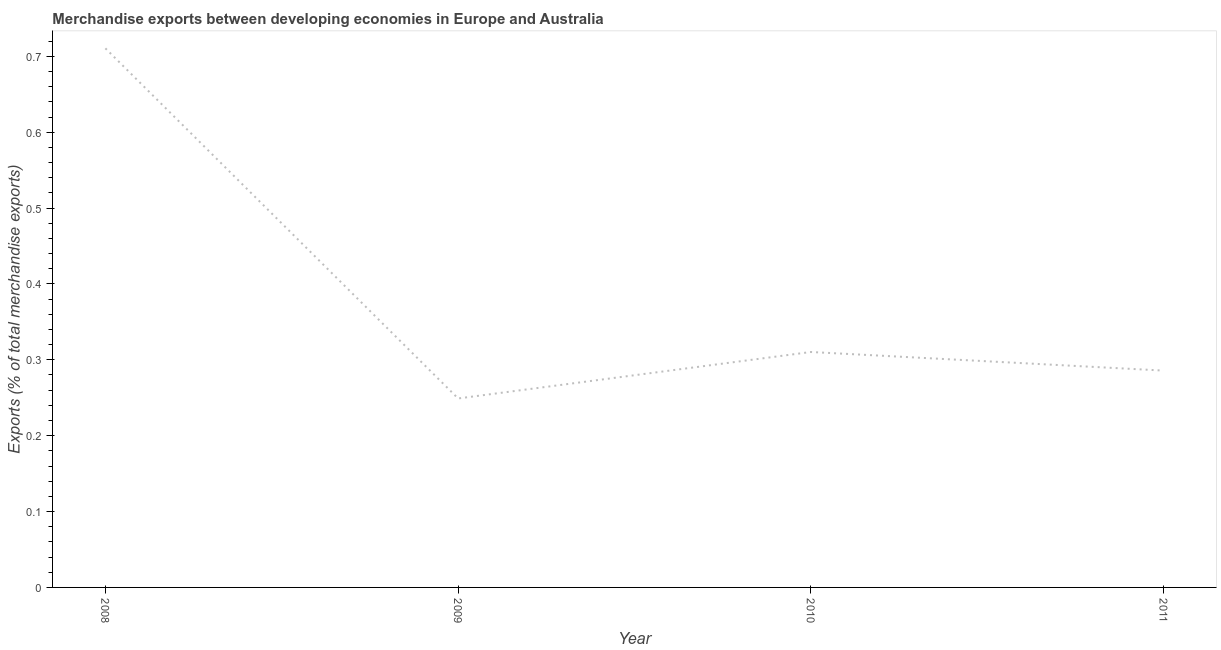What is the merchandise exports in 2011?
Provide a short and direct response. 0.29. Across all years, what is the maximum merchandise exports?
Provide a succinct answer. 0.71. Across all years, what is the minimum merchandise exports?
Provide a succinct answer. 0.25. What is the sum of the merchandise exports?
Offer a terse response. 1.56. What is the difference between the merchandise exports in 2010 and 2011?
Provide a succinct answer. 0.02. What is the average merchandise exports per year?
Your answer should be very brief. 0.39. What is the median merchandise exports?
Keep it short and to the point. 0.3. In how many years, is the merchandise exports greater than 0.16 %?
Provide a succinct answer. 4. What is the ratio of the merchandise exports in 2009 to that in 2010?
Provide a short and direct response. 0.8. Is the merchandise exports in 2010 less than that in 2011?
Your answer should be very brief. No. What is the difference between the highest and the second highest merchandise exports?
Keep it short and to the point. 0.4. What is the difference between the highest and the lowest merchandise exports?
Keep it short and to the point. 0.46. How many lines are there?
Offer a terse response. 1. How many years are there in the graph?
Keep it short and to the point. 4. What is the difference between two consecutive major ticks on the Y-axis?
Provide a short and direct response. 0.1. What is the title of the graph?
Offer a very short reply. Merchandise exports between developing economies in Europe and Australia. What is the label or title of the Y-axis?
Your response must be concise. Exports (% of total merchandise exports). What is the Exports (% of total merchandise exports) of 2008?
Provide a succinct answer. 0.71. What is the Exports (% of total merchandise exports) in 2009?
Your response must be concise. 0.25. What is the Exports (% of total merchandise exports) in 2010?
Offer a very short reply. 0.31. What is the Exports (% of total merchandise exports) of 2011?
Offer a terse response. 0.29. What is the difference between the Exports (% of total merchandise exports) in 2008 and 2009?
Your response must be concise. 0.46. What is the difference between the Exports (% of total merchandise exports) in 2008 and 2010?
Your answer should be compact. 0.4. What is the difference between the Exports (% of total merchandise exports) in 2008 and 2011?
Your response must be concise. 0.42. What is the difference between the Exports (% of total merchandise exports) in 2009 and 2010?
Make the answer very short. -0.06. What is the difference between the Exports (% of total merchandise exports) in 2009 and 2011?
Your answer should be very brief. -0.04. What is the difference between the Exports (% of total merchandise exports) in 2010 and 2011?
Provide a succinct answer. 0.02. What is the ratio of the Exports (% of total merchandise exports) in 2008 to that in 2009?
Make the answer very short. 2.85. What is the ratio of the Exports (% of total merchandise exports) in 2008 to that in 2010?
Provide a succinct answer. 2.29. What is the ratio of the Exports (% of total merchandise exports) in 2008 to that in 2011?
Ensure brevity in your answer.  2.49. What is the ratio of the Exports (% of total merchandise exports) in 2009 to that in 2010?
Offer a terse response. 0.8. What is the ratio of the Exports (% of total merchandise exports) in 2009 to that in 2011?
Make the answer very short. 0.87. What is the ratio of the Exports (% of total merchandise exports) in 2010 to that in 2011?
Offer a terse response. 1.09. 